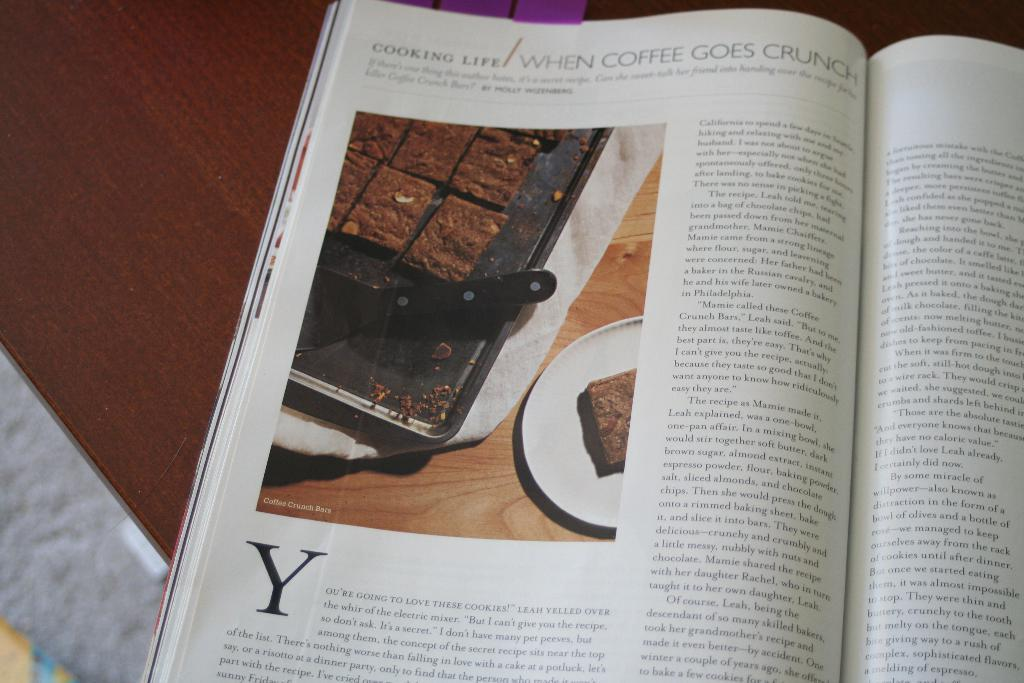<image>
Share a concise interpretation of the image provided. The book Cooking Life opened to a page about Coffee going crunch. 